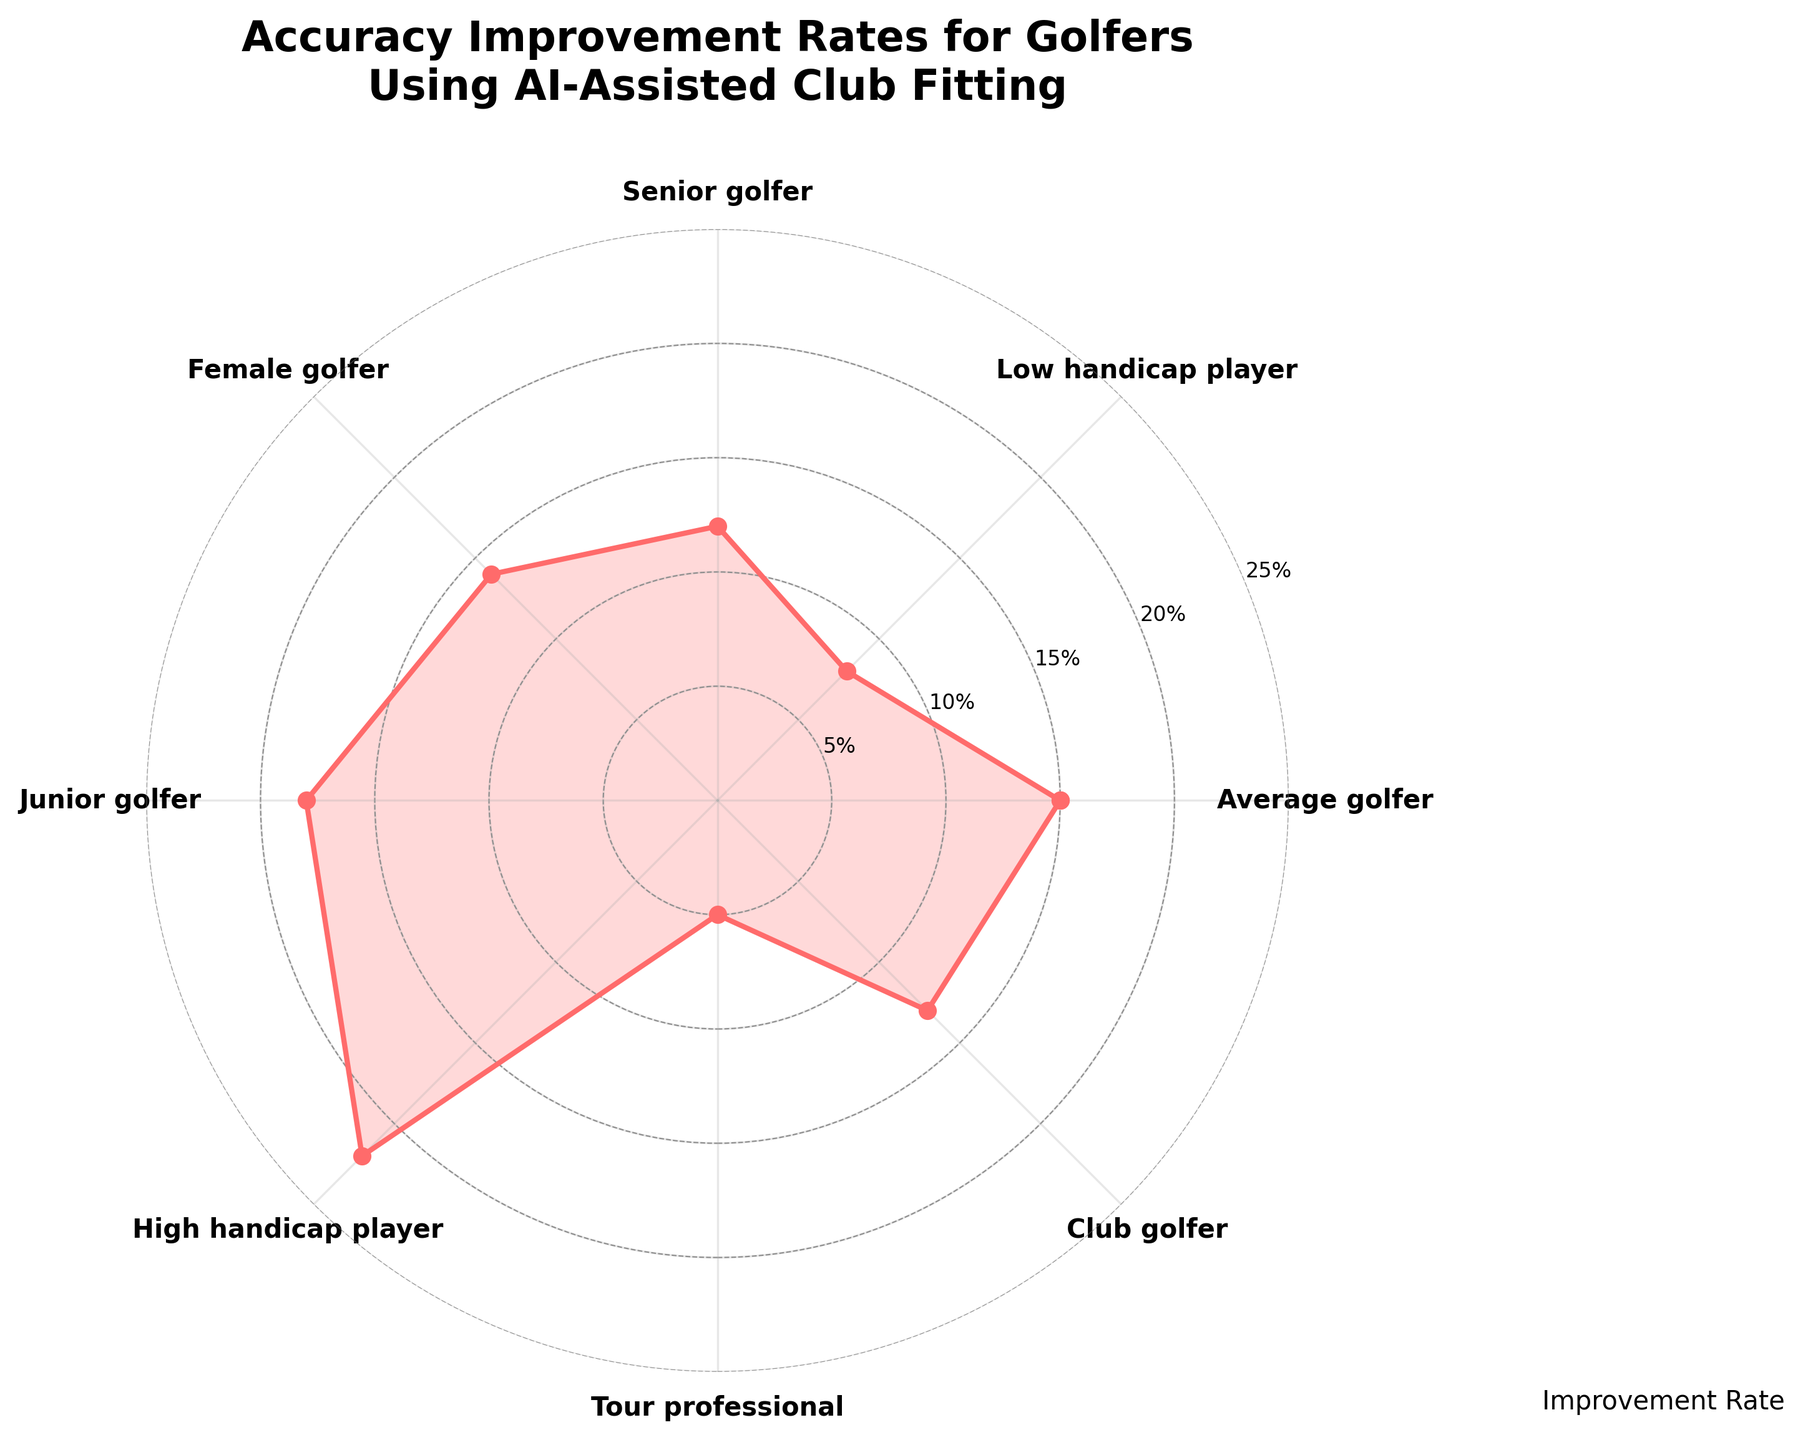What is the title of the figure? The title is placed at the top of the figure, it reads "Accuracy Improvement Rates for Golfers Using AI-Assisted Club Fitting," visible clearly.
Answer: Accuracy Improvement Rates for Golfers Using AI-Assisted Club Fitting How many categories are compared in the figure? The labels on the circular axis represent different categories. Counting them gives eight categories: Average golfer, Low handicap player, Senior golfer, Female golfer, Junior golfer, High handicap player, Tour professional, and Club golfer.
Answer: 8 Which category shows the highest improvement rate in accuracy? By observing the radial lengths, the highest point corresponds to "High handicap player" at 22%.
Answer: High handicap player What is the improvement rate for Tour professionals? The radial length for "Tour professional" is small and matches the label on the y-axis at 5%.
Answer: 5% Which category shows better improvement rates, Female golfers, or Club golfers? Comparing the radial lengths of "Female golfer" and "Club golfer," "Female golfer" reaches 14%, while "Club golfer" reaches 13%.
Answer: Female golfer What is the combined improvement rate of Senior golfers and Female golfers? The rates are 12% for Senior golfers and 14% for Female golfers. Summing these gives 12 + 14 = 26%.
Answer: 26% What is the range of improvement rates shown in the figure? The minimum improvement rate is 5% (Tour professional) and the maximum is 22% (High handicap player), so the range is 22 - 5 = 17%.
Answer: 17% Are the improvement rates of Average golfers and Junior golfers the same or different? The radial lengths for "Average golfer" and "Junior golfer" are compared; they show different values, 15% and 18%, respectively.
Answer: Different Does any category have an accuracy improvement rate exactly at 50% of the maximum value shown on the y-axis? The maximum on the y-axis is 25%, and 50% of this is 12.5%. No category corresponds exactly to 12.5%, but Senior golfers are closest with 12%.
Answer: No Which two categories have the smallest difference in their improvement rates? Inspecting the data visually, "Female golfer" (14%) and "Club golfer" (13%) have a difference of 1%, which is the smallest difference among all categories.
Answer: Female golfer and Club golfer 